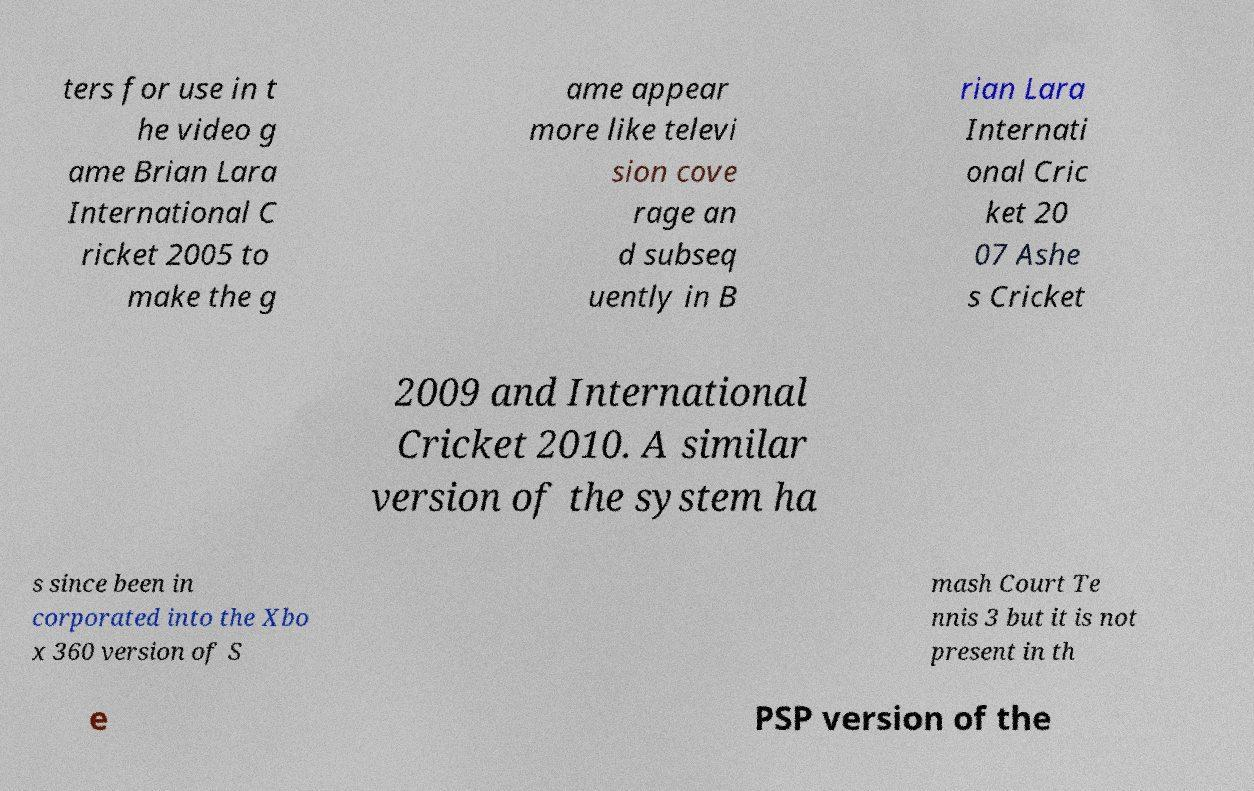I need the written content from this picture converted into text. Can you do that? ters for use in t he video g ame Brian Lara International C ricket 2005 to make the g ame appear more like televi sion cove rage an d subseq uently in B rian Lara Internati onal Cric ket 20 07 Ashe s Cricket 2009 and International Cricket 2010. A similar version of the system ha s since been in corporated into the Xbo x 360 version of S mash Court Te nnis 3 but it is not present in th e PSP version of the 